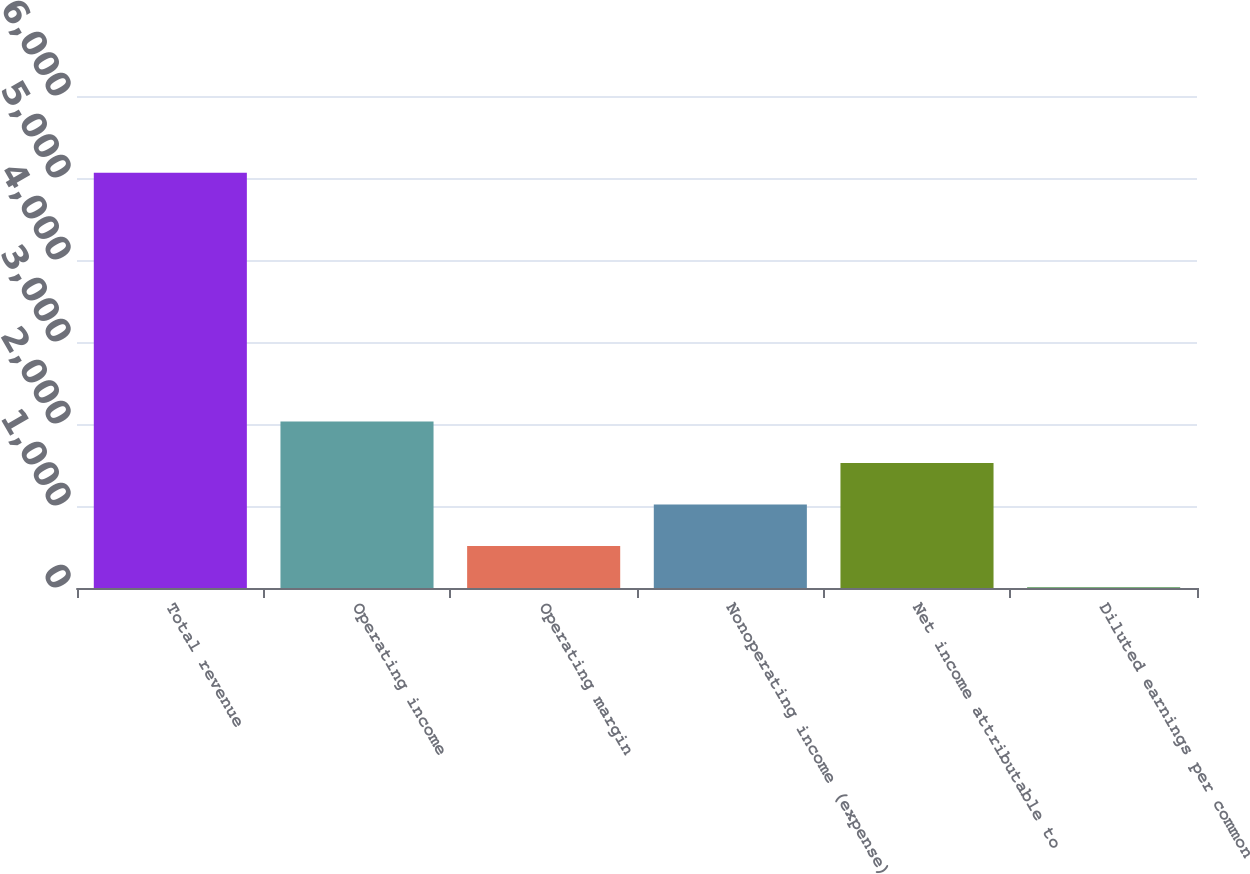Convert chart. <chart><loc_0><loc_0><loc_500><loc_500><bar_chart><fcel>Total revenue<fcel>Operating income<fcel>Operating margin<fcel>Nonoperating income (expense)<fcel>Net income attributable to<fcel>Diluted earnings per common<nl><fcel>5064<fcel>2029.06<fcel>511.6<fcel>1017.42<fcel>1523.24<fcel>5.78<nl></chart> 